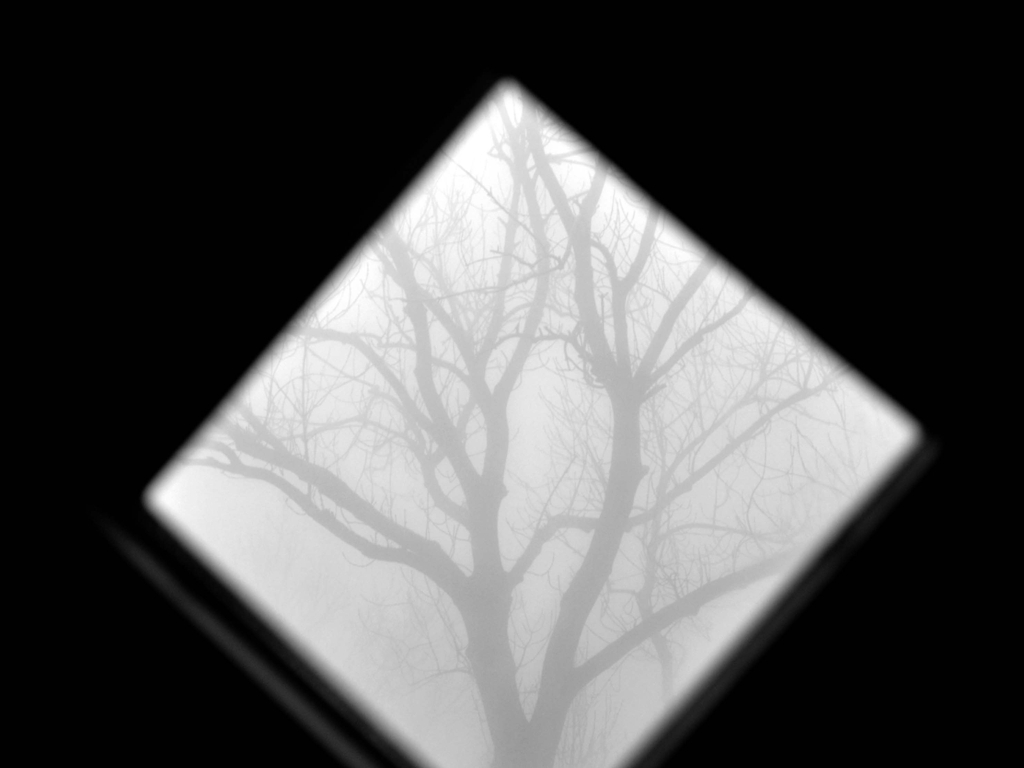Is the quality of the image above average?
A. No
B. Yes While the image exhibits a minimalist aesthetic with a strong contrast between the tree and the surrounding mist, which can be considered a stylistic choice and conveys a certain mood, some might argue that it lacks sharpness, color diversity, and details that are often associated with 'above average' quality in the context of clarity and resolution. Therefore, when judging the quality based on technical aspects such as clarity and variety of detail, the answer would be A. No. 